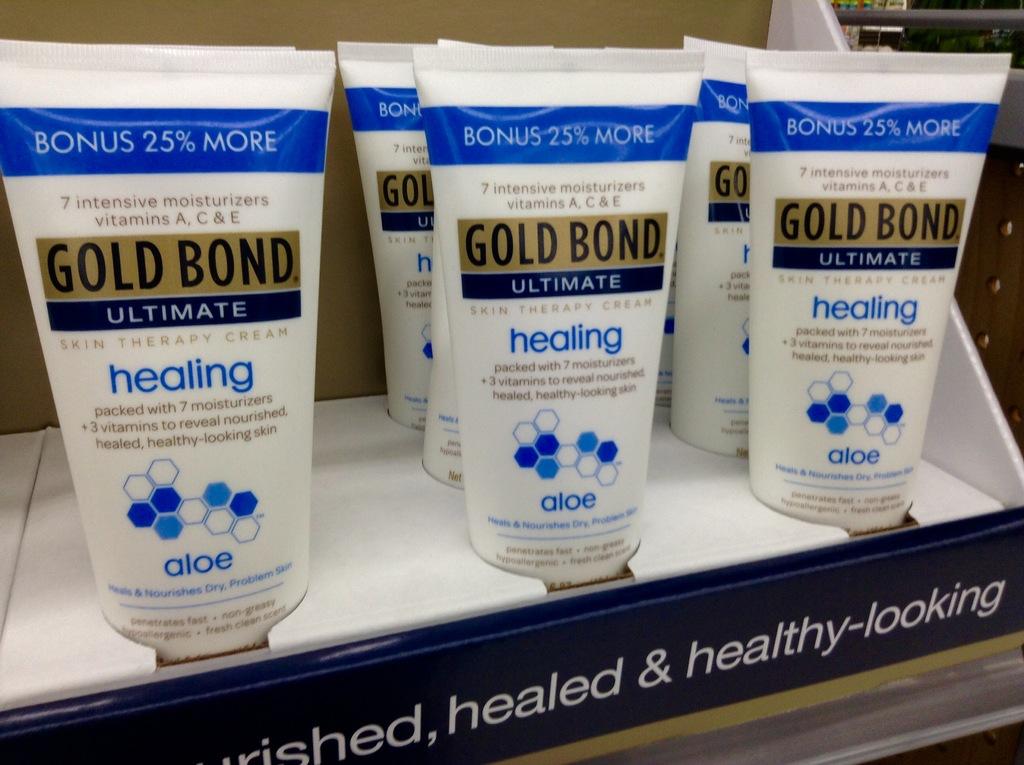How much extra cream is included?
Make the answer very short. 25%. What brand is this cream?
Your response must be concise. Gold bond. 